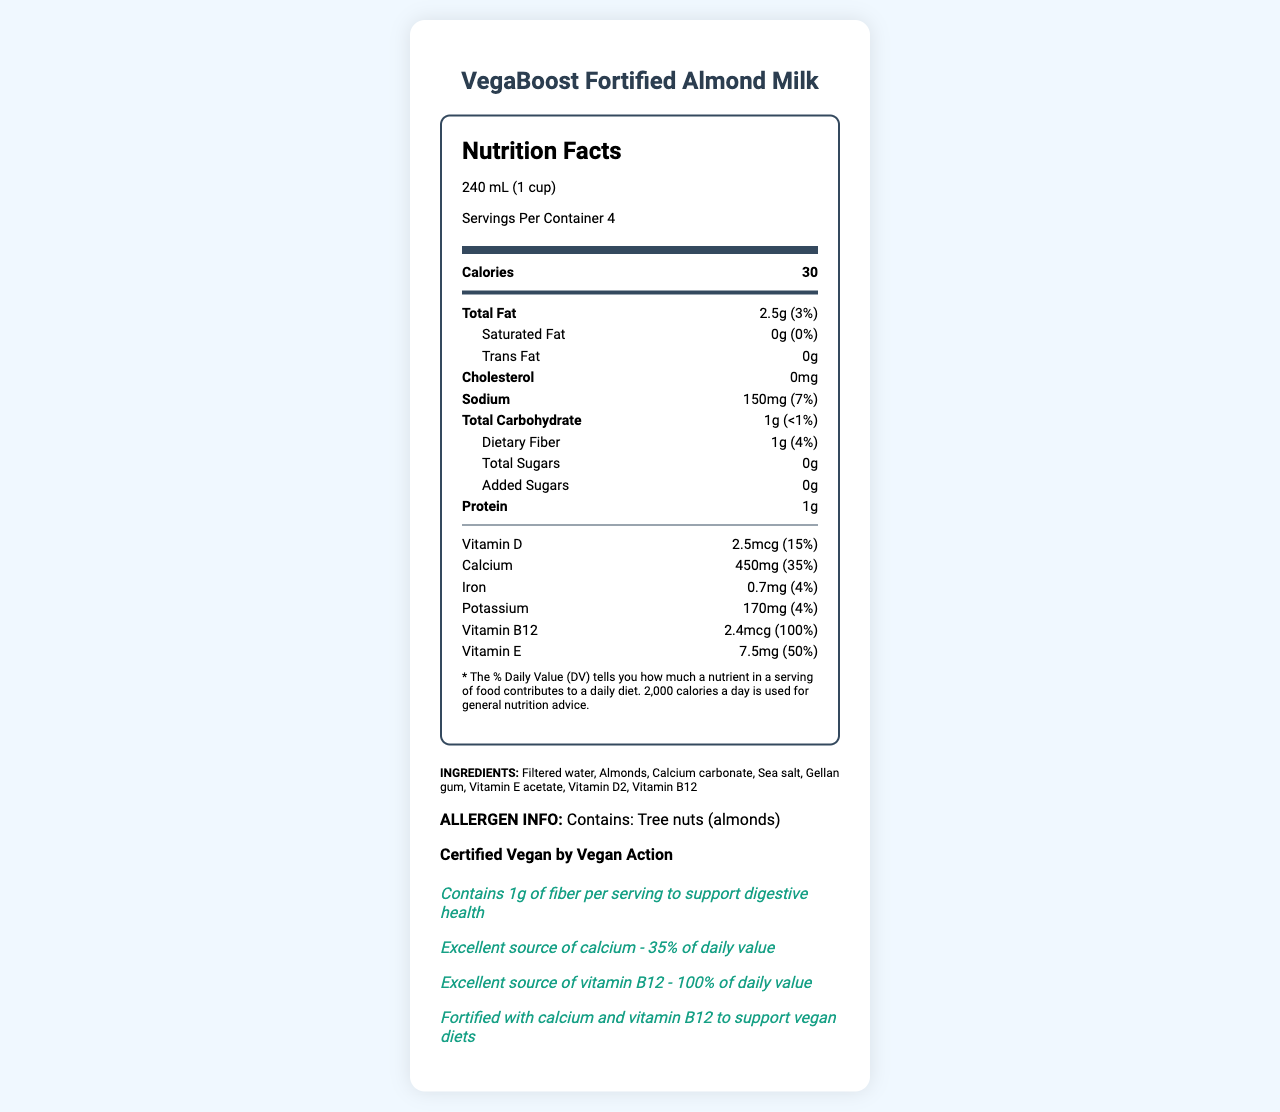what is the serving size? The serving size is specified at the top of the Nutrition Facts label, under the product name and above the list of nutrients.
Answer: 240 mL (1 cup) how many servings are there per container? The number of servings per container is listed right below the serving size.
Answer: 4 how much calcium does a serving of VegaBoost Fortified Almond Milk provide? The amount of calcium per serving is listed in the Nutrition Facts section, under the vitamins and minerals.
Answer: 450 mg what percentage of the daily value of vitamin B12 is in one serving? The daily value percentage for vitamin B12 is provided next to its amount in the vitamins and minerals section.
Answer: 100% what is the total fat content per serving and its daily value percentage? The total fat content is listed in the Nutrition Facts section along with its daily value percentage underneath the thick divider after the calorie count.
Answer: 2.5g, 3% what is the calories per serving value? The calorie count is prominently listed in the Nutrition Facts section, directly below the serving information.
Answer: 30 how much sodium is in a serving? The sodium content is part of the Nutrition Facts section, listed under cholesterol and above the total carbohydrate information.
Answer: 150 mg which ingredient is listed first? A. Sea salt B. Almonds C. Filtered water The list of ingredients shows "Filtered water" as the first item, indicating it is the primary ingredient by weight.
Answer: C. Filtered water how much dietary fiber and its daily value percentage does this milk provide per serving? The dietary fiber content and its daily value percentage are listed as a sub-nutrient under total carbohydrates.
Answer: 1g, 4% is this product certified vegan? The document includes a statement: "Certified Vegan by Vegan Action."
Answer: Yes does this product contain any cholesterol? The cholesterol content is stated as "0mg" in the Nutrition Facts section.
Answer: No what are the main nutritional benefits of VegaBoost Fortified Almond Milk? The claims section highlights that this product is an excellent source of vitamin B12 (100% DV) and calcium (35% DV), along with additional benefits for digestive health due to fiber content.
Answer: High in vitamin B12 and calcium how long has VegaBoost Fortified Almond Milk been on the market? The document does not provide any information regarding the product's market duration.
Answer: I don't know 